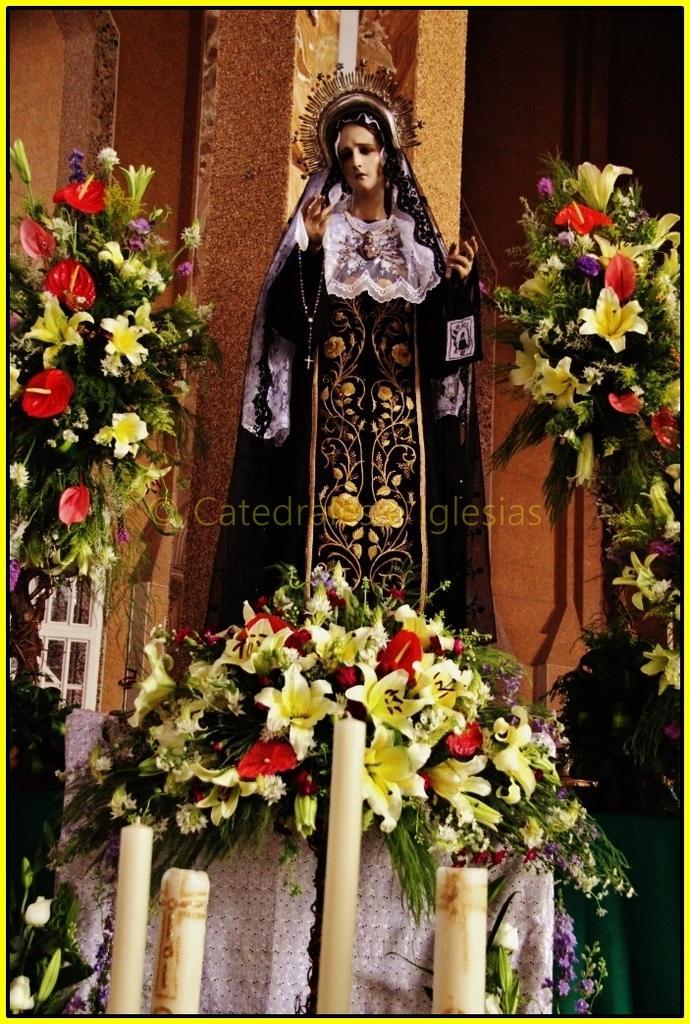Please provide a concise description of this image. In this image, there is a person standing and wearing clothes. There are some flowers on the left and on the right side of the image. There are candles and some flowers at the bottom of the image. 